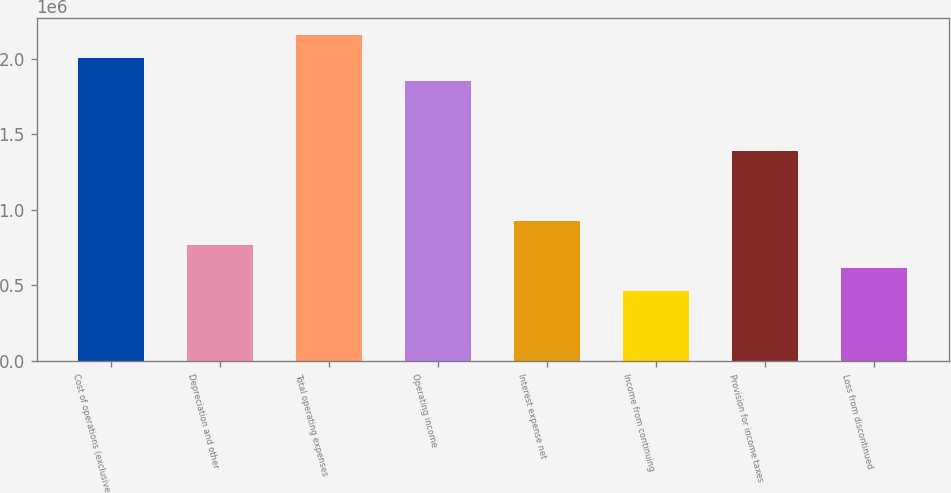Convert chart to OTSL. <chart><loc_0><loc_0><loc_500><loc_500><bar_chart><fcel>Cost of operations (exclusive<fcel>Depreciation and other<fcel>Total operating expenses<fcel>Operating income<fcel>Interest expense net<fcel>Income from continuing<fcel>Provision for income taxes<fcel>Loss from discontinued<nl><fcel>2.00321e+06<fcel>770468<fcel>2.15731e+06<fcel>1.84912e+06<fcel>924561<fcel>462282<fcel>1.38684e+06<fcel>616375<nl></chart> 